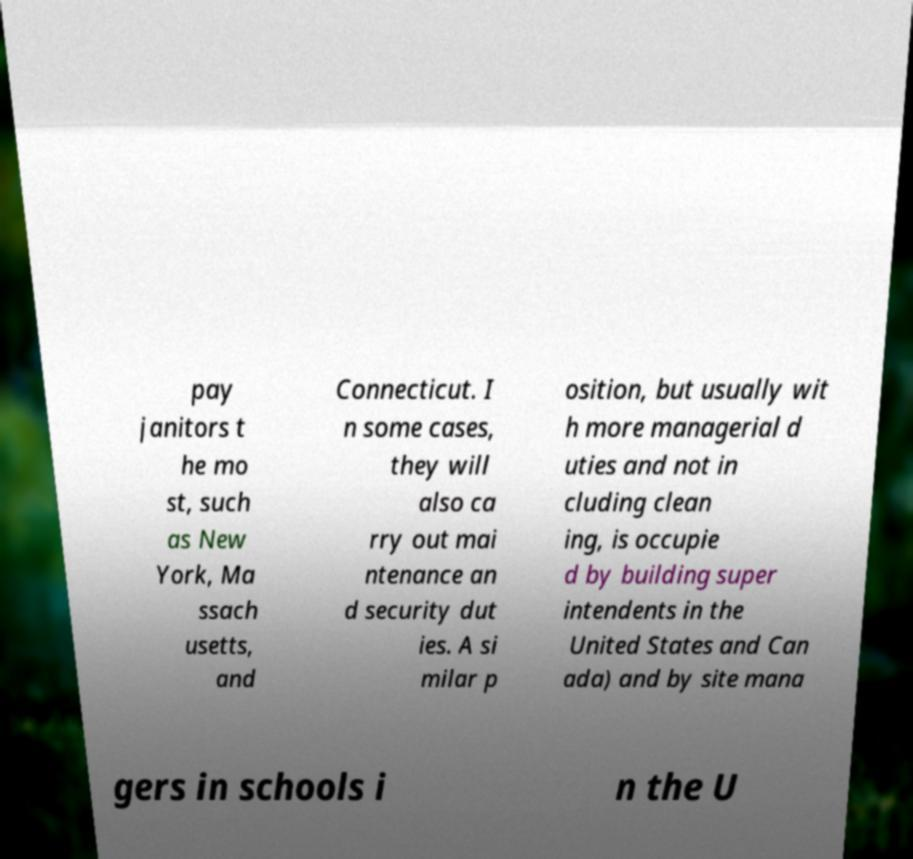Could you extract and type out the text from this image? pay janitors t he mo st, such as New York, Ma ssach usetts, and Connecticut. I n some cases, they will also ca rry out mai ntenance an d security dut ies. A si milar p osition, but usually wit h more managerial d uties and not in cluding clean ing, is occupie d by building super intendents in the United States and Can ada) and by site mana gers in schools i n the U 